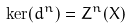Convert formula to latex. <formula><loc_0><loc_0><loc_500><loc_500>\ker ( d ^ { n } ) = Z ^ { n } ( X )</formula> 